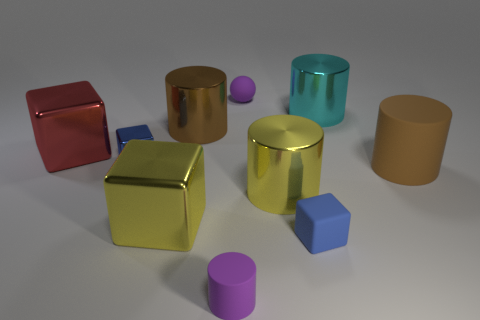What number of large yellow cubes have the same material as the yellow cylinder?
Ensure brevity in your answer.  1. Is the brown shiny thing the same size as the cyan shiny thing?
Your answer should be very brief. Yes. Are there any other things that are the same color as the tiny matte cube?
Ensure brevity in your answer.  Yes. The matte thing that is both on the left side of the blue rubber cube and in front of the tiny shiny cube has what shape?
Offer a terse response. Cylinder. What is the size of the blue cube that is on the left side of the tiny rubber ball?
Your answer should be compact. Small. What number of big shiny cylinders are behind the big yellow cylinder that is left of the tiny blue block that is to the right of the tiny sphere?
Give a very brief answer. 2. Are there any large rubber cylinders on the left side of the tiny purple rubber sphere?
Make the answer very short. No. What number of other objects are the same size as the red metal object?
Give a very brief answer. 5. There is a cylinder that is both behind the rubber cube and in front of the big rubber thing; what material is it?
Offer a very short reply. Metal. There is a large yellow thing right of the yellow block; is it the same shape as the tiny matte object on the right side of the rubber ball?
Your response must be concise. No. 